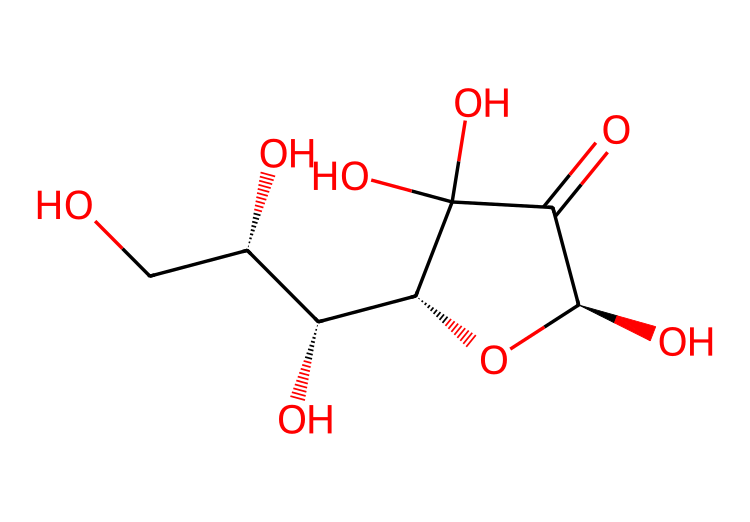how many carbon atoms are in vitamin C? The chemical structure can be analyzed to count the carbon (C) atoms. Upon inspecting, there are six carbon atoms in the structure.
Answer: six how many hydroxyl (–OH) groups are present? The structure shows several –OH groups visibly attached to the carbon framework. Counting them, we find there are four hydroxyl groups.
Answer: four what is the molecular formula of vitamin C? From the structure and counting each type of atom, the molecular formula derived is C6H8O6. This is a standard representation of vitamin C.
Answer: C6H8O6 what distinguishes vitamin C as an antioxidant? The presence of multiple hydroxyl groups contributes to its ability to donate electrons, stabilizing free radicals and making it an effective antioxidant. This defines its chemical behavior in biological systems.
Answer: hydroxyl groups how many oxygen atoms are within the structure? Analyzing the chemical structure for oxygen (O) atoms, we find that there are six oxygen atoms attached to the carbon skeleton and as part of functional groups.
Answer: six why is vitamin C important for health? Vitamin C is crucial because it plays a role in collagen synthesis, improving immune function, and enhancing iron absorption. Its antioxidant properties further support cellular health by protecting against oxidative stress.
Answer: immune function how does vitamin C contribute to skin health? Vitamin C is involved in collagen production, which is essential for skin structure and resilience. Its antioxidant properties help protect skin cells from damage caused by UV light and pollution.
Answer: collagen production 